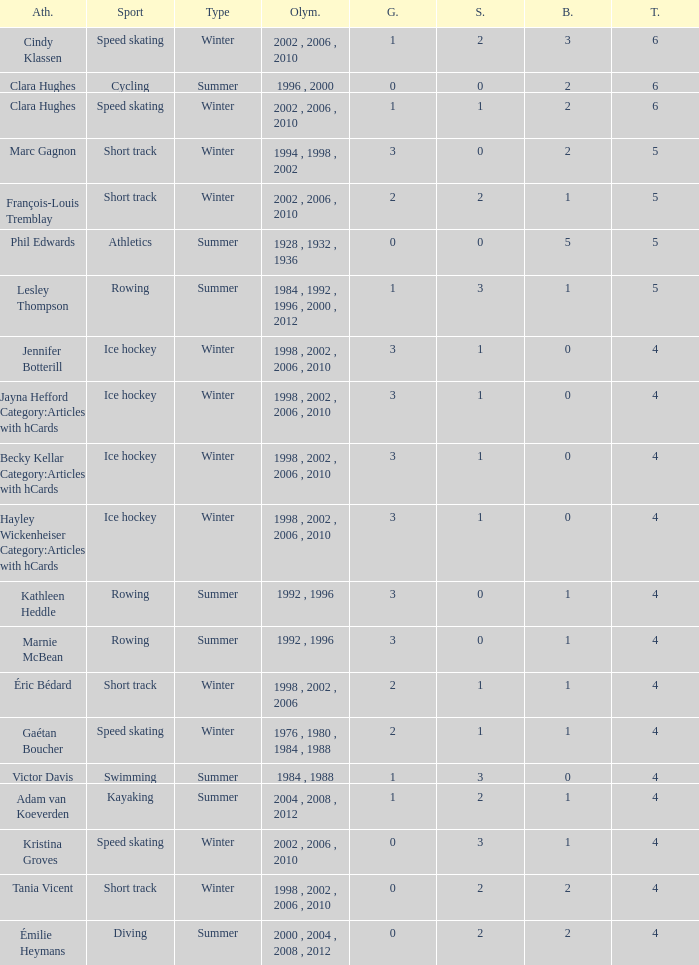What is the average gold of the winter athlete with 1 bronze, less than 3 silver, and less than 4 total medals? None. 